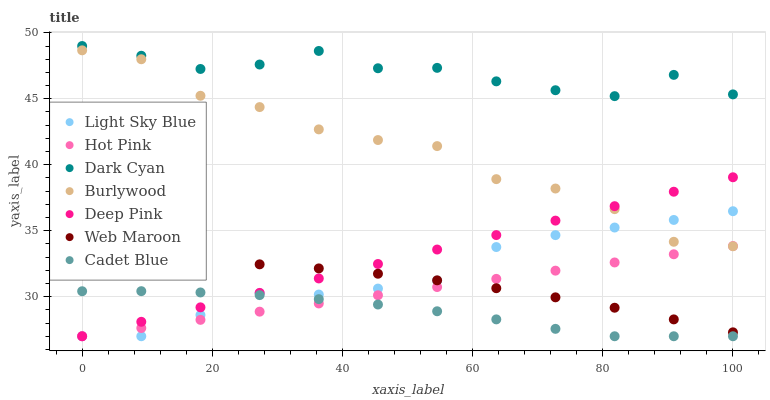Does Cadet Blue have the minimum area under the curve?
Answer yes or no. Yes. Does Dark Cyan have the maximum area under the curve?
Answer yes or no. Yes. Does Burlywood have the minimum area under the curve?
Answer yes or no. No. Does Burlywood have the maximum area under the curve?
Answer yes or no. No. Is Hot Pink the smoothest?
Answer yes or no. Yes. Is Burlywood the roughest?
Answer yes or no. Yes. Is Burlywood the smoothest?
Answer yes or no. No. Is Hot Pink the roughest?
Answer yes or no. No. Does Deep Pink have the lowest value?
Answer yes or no. Yes. Does Burlywood have the lowest value?
Answer yes or no. No. Does Dark Cyan have the highest value?
Answer yes or no. Yes. Does Burlywood have the highest value?
Answer yes or no. No. Is Hot Pink less than Dark Cyan?
Answer yes or no. Yes. Is Dark Cyan greater than Cadet Blue?
Answer yes or no. Yes. Does Cadet Blue intersect Deep Pink?
Answer yes or no. Yes. Is Cadet Blue less than Deep Pink?
Answer yes or no. No. Is Cadet Blue greater than Deep Pink?
Answer yes or no. No. Does Hot Pink intersect Dark Cyan?
Answer yes or no. No. 